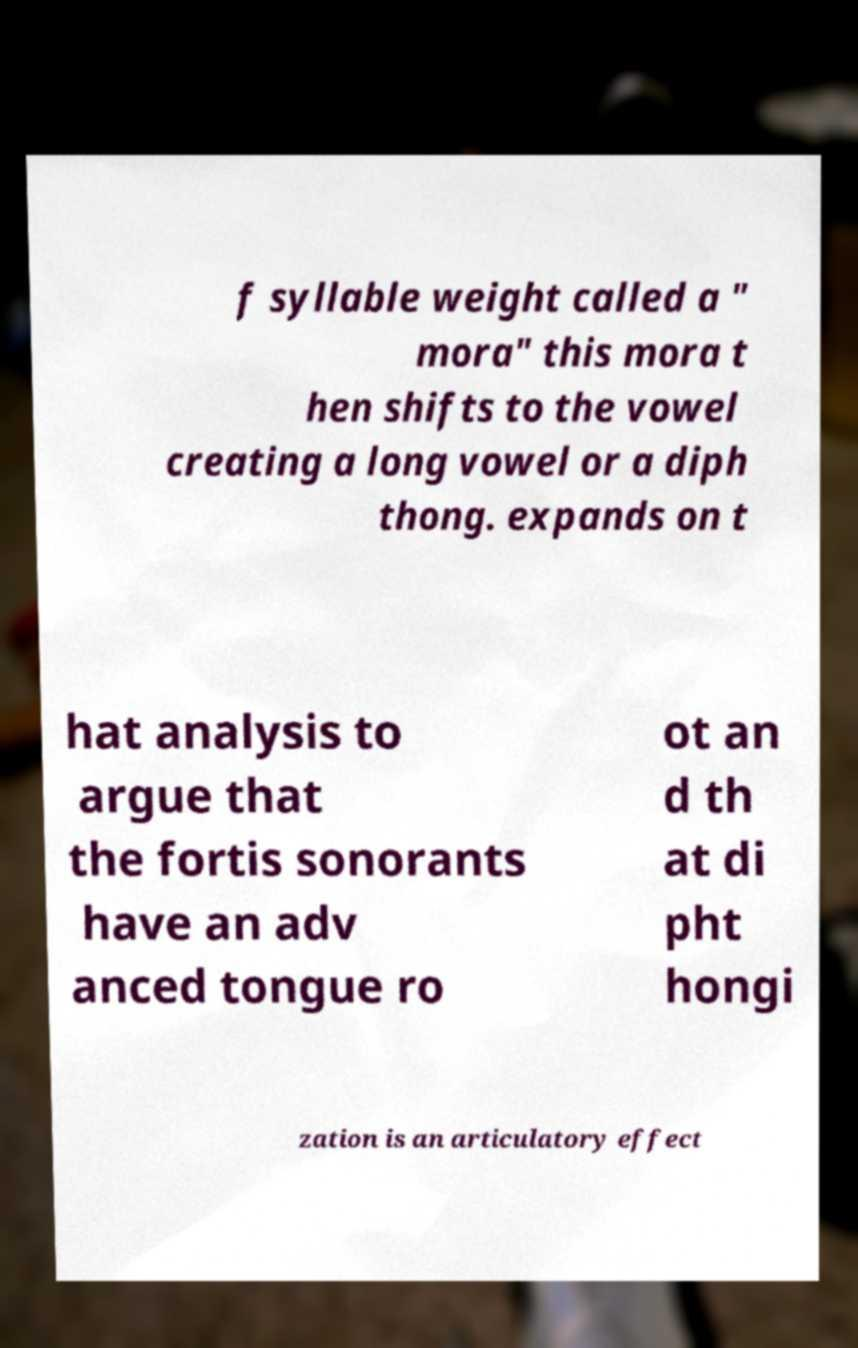What messages or text are displayed in this image? I need them in a readable, typed format. f syllable weight called a " mora" this mora t hen shifts to the vowel creating a long vowel or a diph thong. expands on t hat analysis to argue that the fortis sonorants have an adv anced tongue ro ot an d th at di pht hongi zation is an articulatory effect 